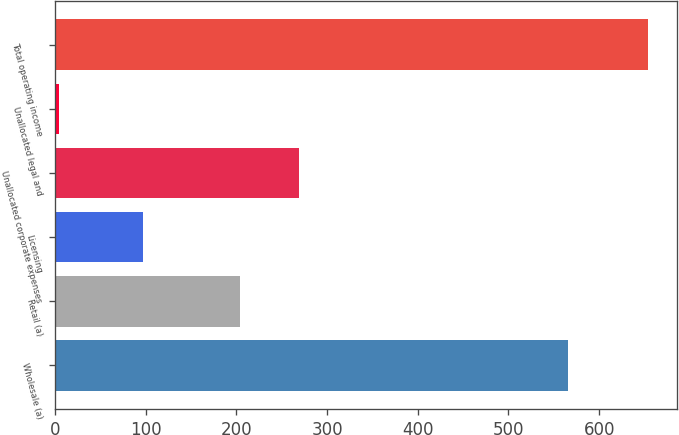Convert chart to OTSL. <chart><loc_0><loc_0><loc_500><loc_500><bar_chart><fcel>Wholesale (a)<fcel>Retail (a)<fcel>Licensing<fcel>Unallocated corporate expenses<fcel>Unallocated legal and<fcel>Total operating income<nl><fcel>565.4<fcel>204.2<fcel>96.7<fcel>269.13<fcel>4.1<fcel>653.4<nl></chart> 